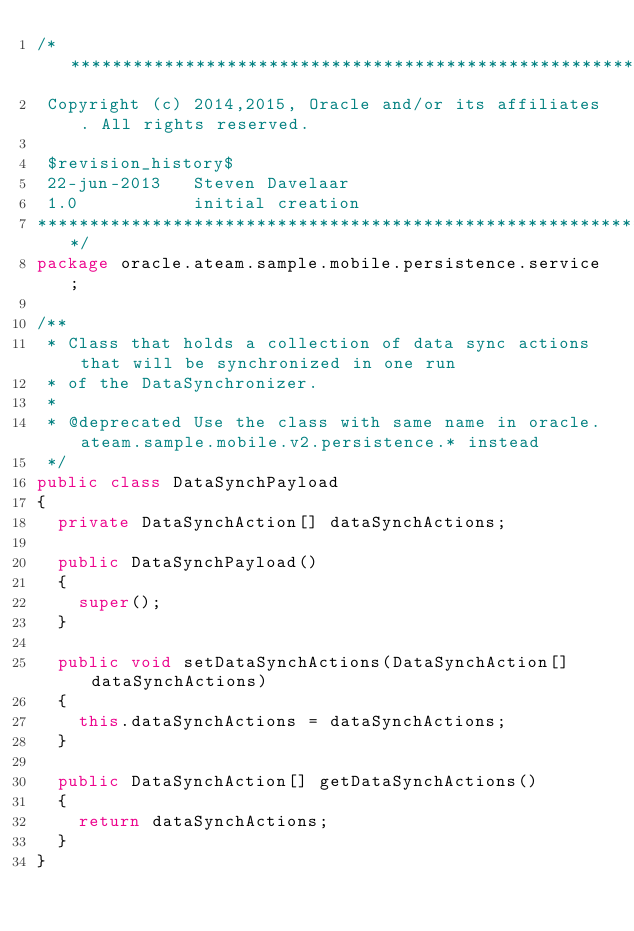<code> <loc_0><loc_0><loc_500><loc_500><_Java_>/*******************************************************************************
 Copyright (c) 2014,2015, Oracle and/or its affiliates. All rights reserved.
 
 $revision_history$
 22-jun-2013   Steven Davelaar
 1.0           initial creation
******************************************************************************/
package oracle.ateam.sample.mobile.persistence.service;

/**
 * Class that holds a collection of data sync actions that will be synchronized in one run
 * of the DataSynchronizer.
 * 
 * @deprecated Use the class with same name in oracle.ateam.sample.mobile.v2.persistence.* instead
 */
public class DataSynchPayload
{
  private DataSynchAction[] dataSynchActions;

  public DataSynchPayload()
  {
    super();
  }

  public void setDataSynchActions(DataSynchAction[] dataSynchActions)
  {
    this.dataSynchActions = dataSynchActions;
  }

  public DataSynchAction[] getDataSynchActions()
  {
    return dataSynchActions;
  }
}
</code> 